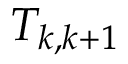Convert formula to latex. <formula><loc_0><loc_0><loc_500><loc_500>T _ { k , k + 1 }</formula> 